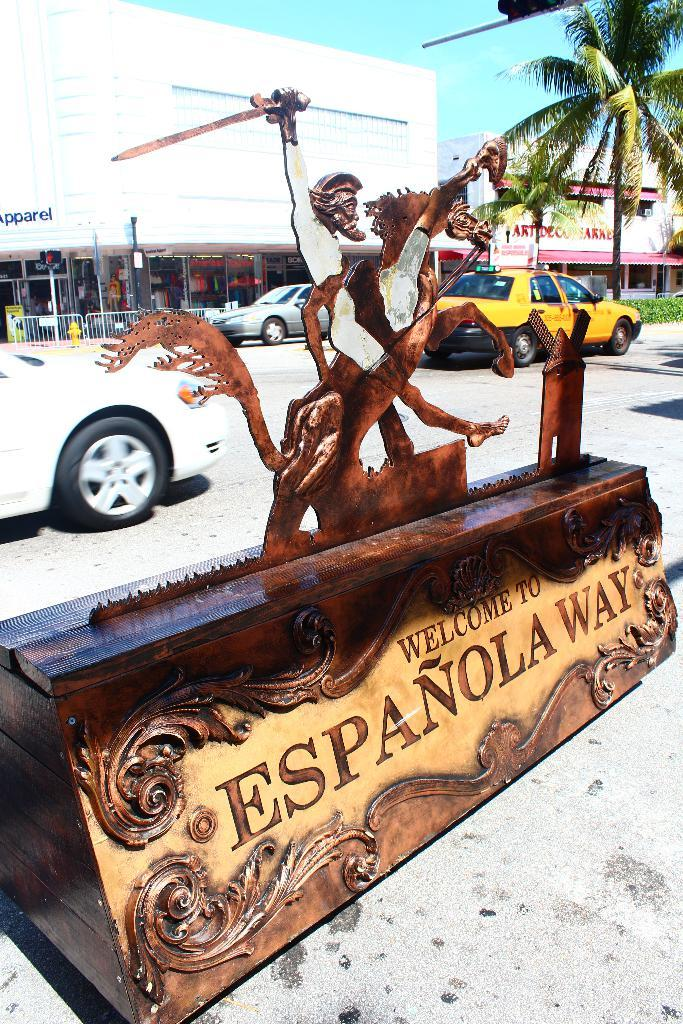<image>
Create a compact narrative representing the image presented. A wooden sculpture says "welcome to Espanola Way" 